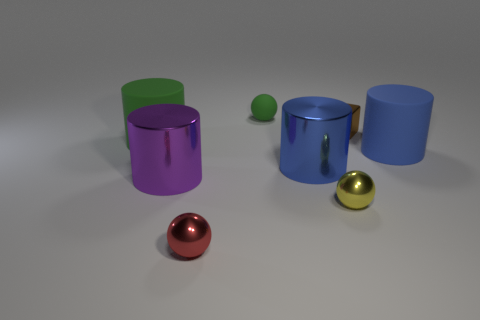How many objects are there in the image, and can you describe them? There are five objects in the image. Starting from the left, there is a green transparent cylinder, a shiny purple cylinder, a small green sphere, a metallic blue cylinder, and a smaller blue cylinder. Additionally, there are two spheres in the front - one red and one yellow gold, both with reflective surfaces. 